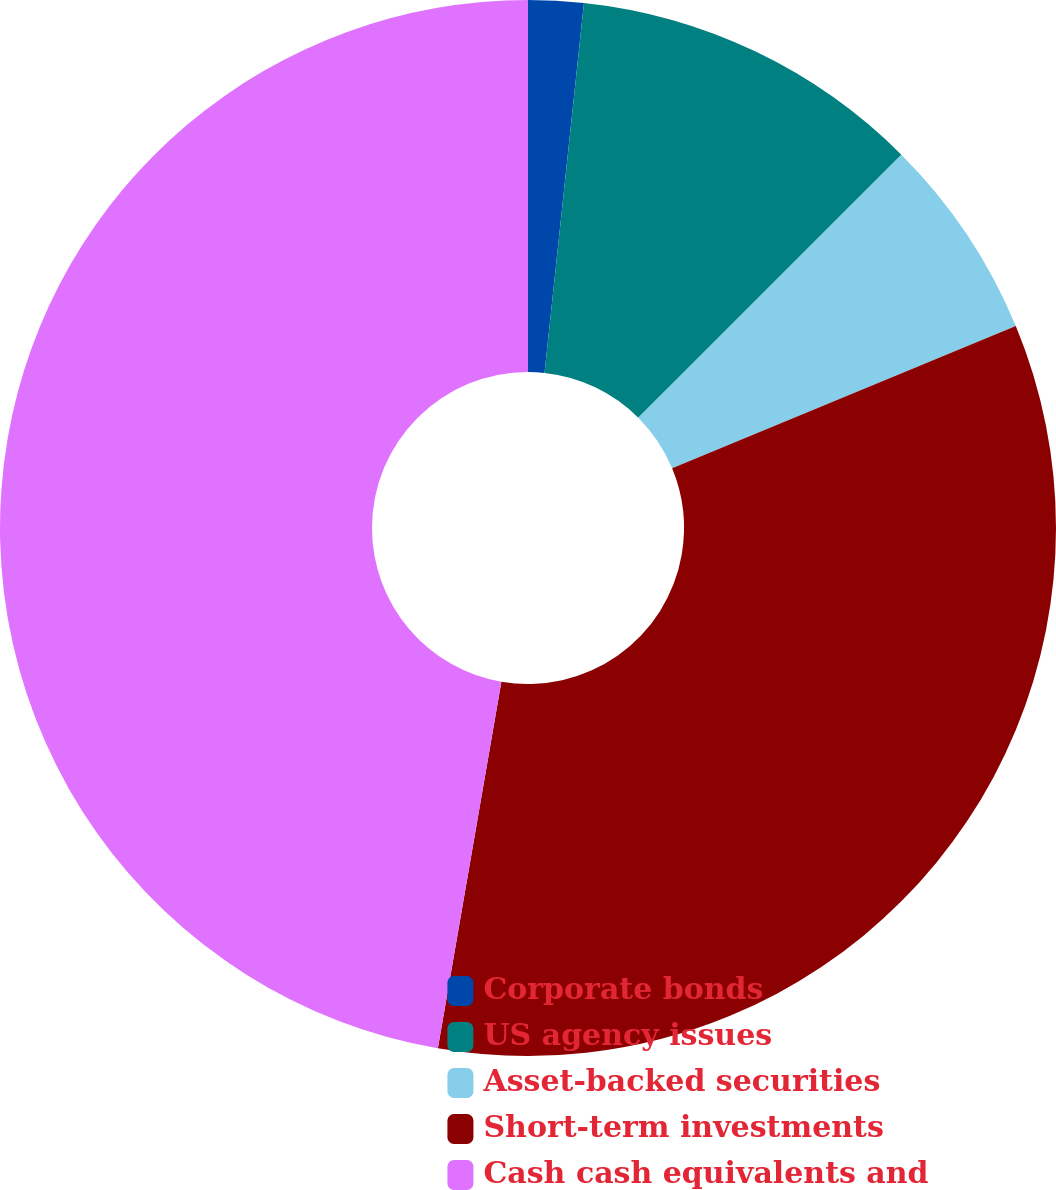Convert chart. <chart><loc_0><loc_0><loc_500><loc_500><pie_chart><fcel>Corporate bonds<fcel>US agency issues<fcel>Asset-backed securities<fcel>Short-term investments<fcel>Cash cash equivalents and<nl><fcel>1.69%<fcel>10.81%<fcel>6.25%<fcel>33.98%<fcel>47.27%<nl></chart> 